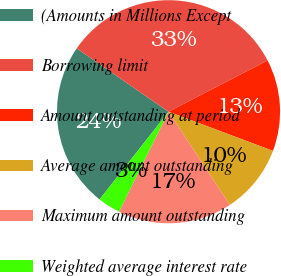Convert chart to OTSL. <chart><loc_0><loc_0><loc_500><loc_500><pie_chart><fcel>(Amounts in Millions Except<fcel>Borrowing limit<fcel>Amount outstanding at period<fcel>Average amount outstanding<fcel>Maximum amount outstanding<fcel>Weighted average interest rate<nl><fcel>24.01%<fcel>32.79%<fcel>13.31%<fcel>10.03%<fcel>16.58%<fcel>3.28%<nl></chart> 